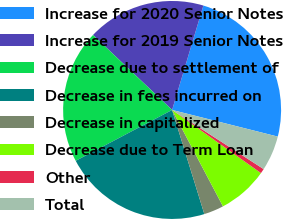Convert chart. <chart><loc_0><loc_0><loc_500><loc_500><pie_chart><fcel>Increase for 2020 Senior Notes<fcel>Increase for 2019 Senior Notes<fcel>Decrease due to settlement of<fcel>Decrease in fees incurred on<fcel>Decrease in capitalized<fcel>Decrease due to Term Loan<fcel>Other<fcel>Total<nl><fcel>24.3%<fcel>17.56%<fcel>19.8%<fcel>22.05%<fcel>2.95%<fcel>7.44%<fcel>0.7%<fcel>5.2%<nl></chart> 